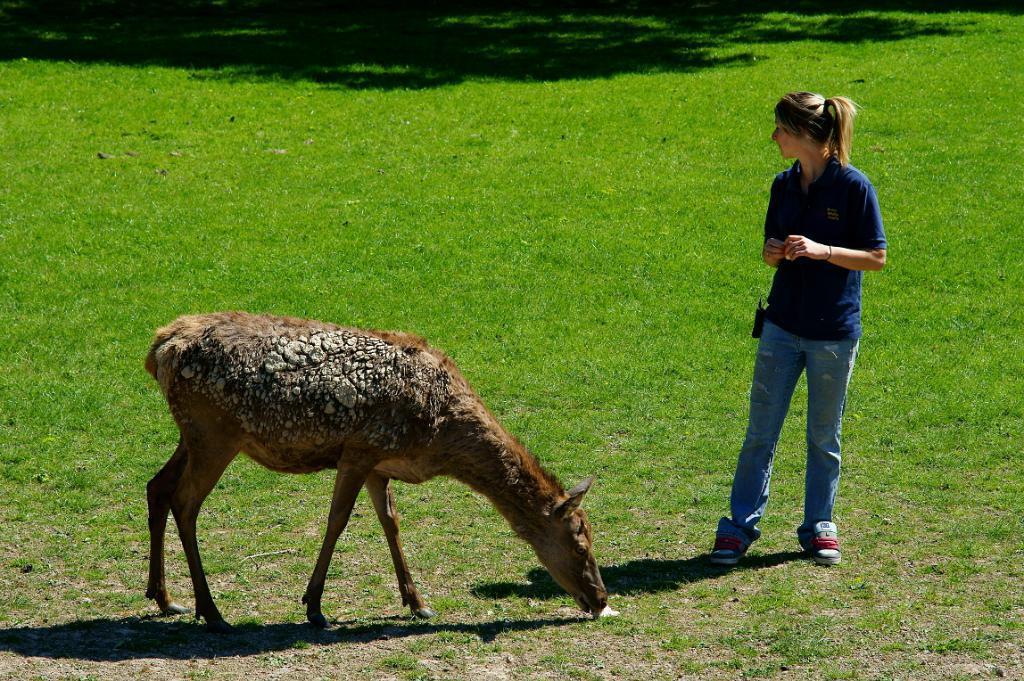In one or two sentences, can you explain what this image depicts? In this image, we can see an animal. There is a person on the right side of the image standing and wearing clothes. There is a grass on the ground. 